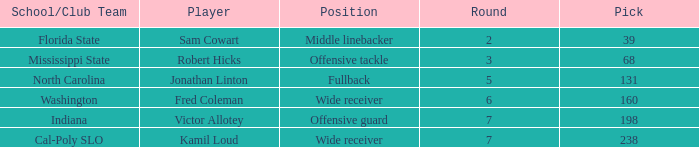Which Round has a School/Club Team of north carolina, and a Pick larger than 131? 0.0. 